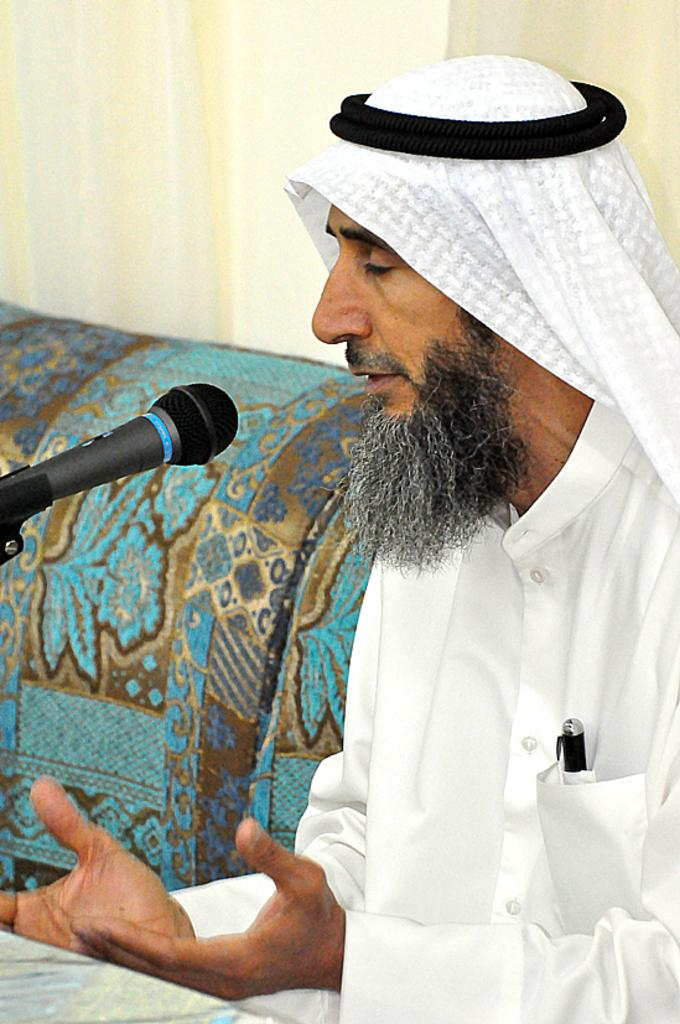What is the man in the image doing? The man is sitting in the image. What object is in front of the man? A microphone is present in front of the man. What type of furniture is in the image? There is a sofa in the image. What can be seen in the background of the image? There is a curtain in the background of the image. What type of oatmeal is being served on the field in the image? There is no field or oatmeal present in the image. 